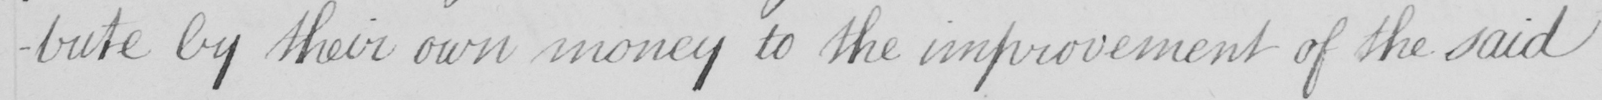Can you read and transcribe this handwriting? -bute by their own money to the improvement of the said 